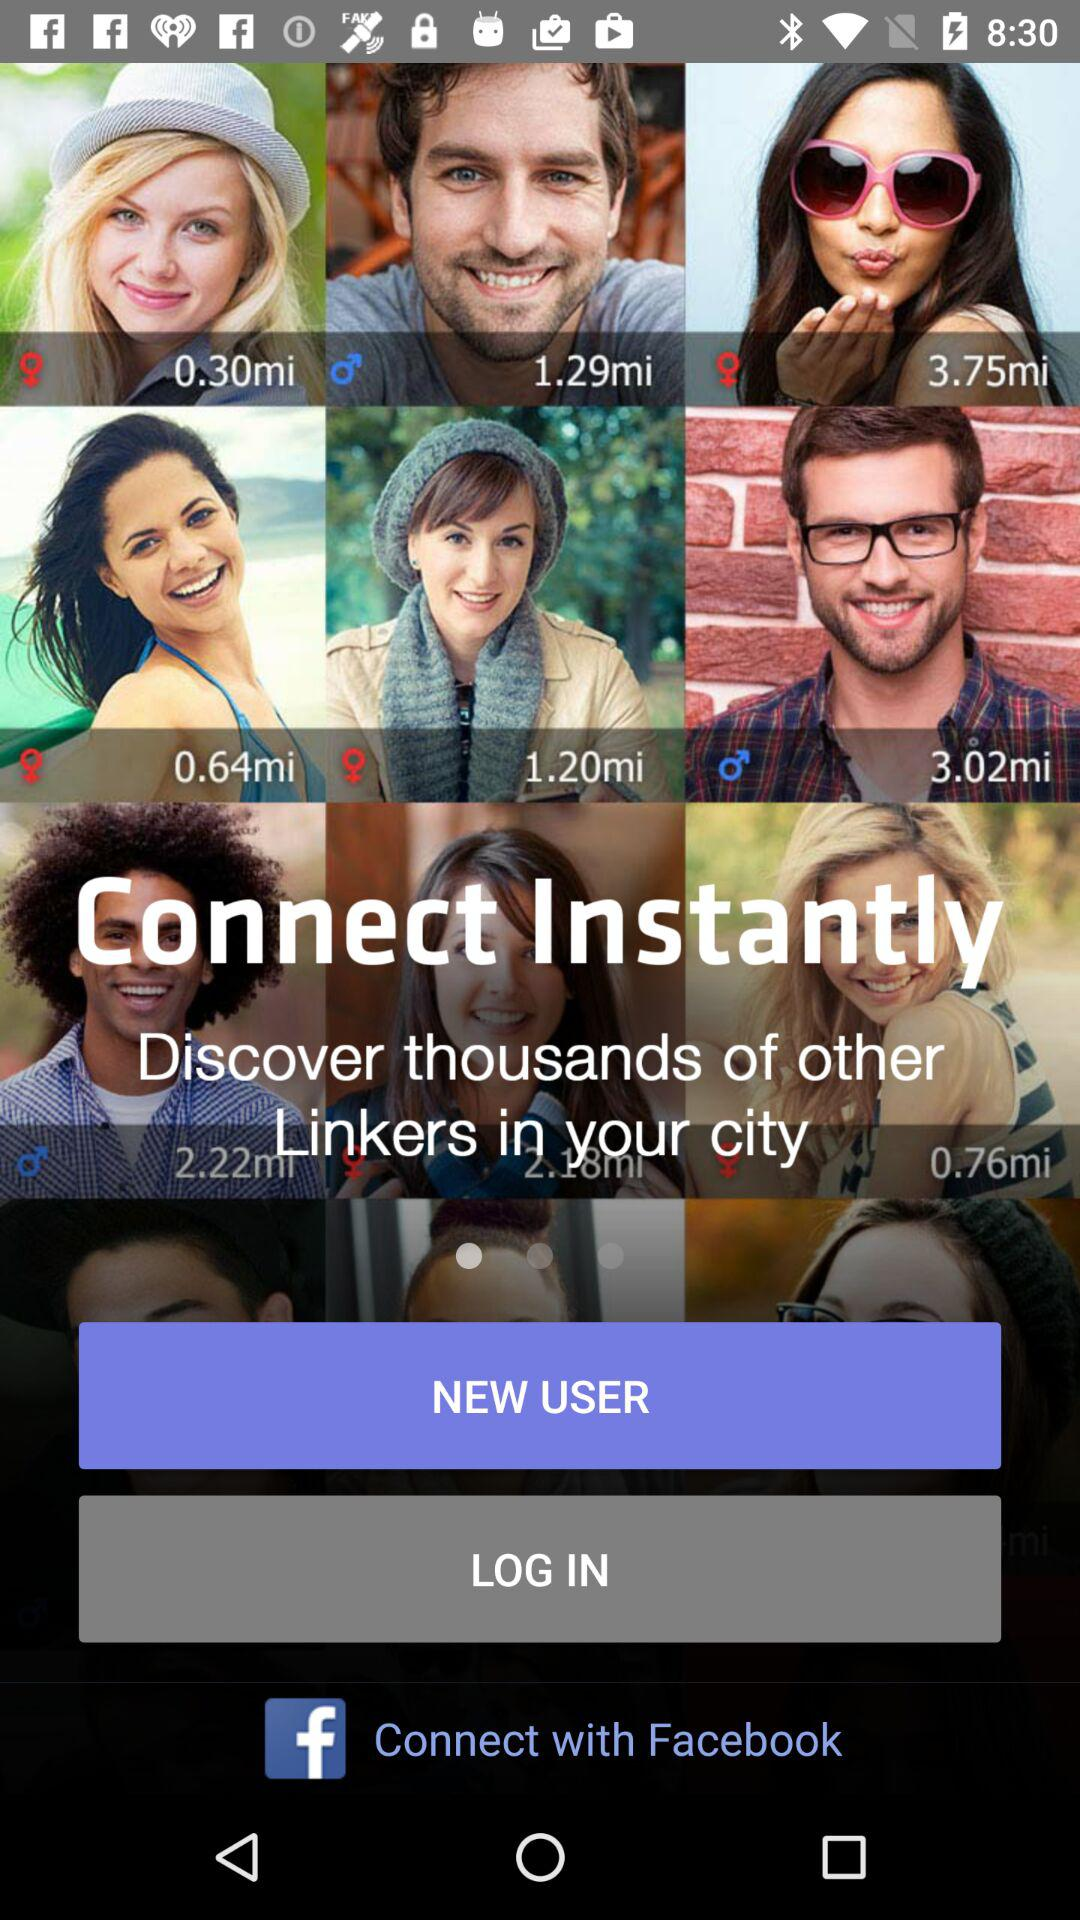Who lives 1.2 miles away?
When the provided information is insufficient, respond with <no answer>. <no answer> 